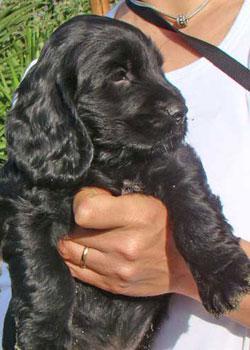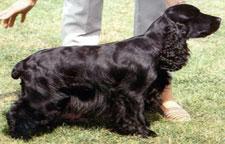The first image is the image on the left, the second image is the image on the right. For the images shown, is this caption "At least one dog is being held in someone's hands." true? Answer yes or no. Yes. The first image is the image on the left, the second image is the image on the right. Considering the images on both sides, is "the right pic has human shoes in it" valid? Answer yes or no. Yes. 